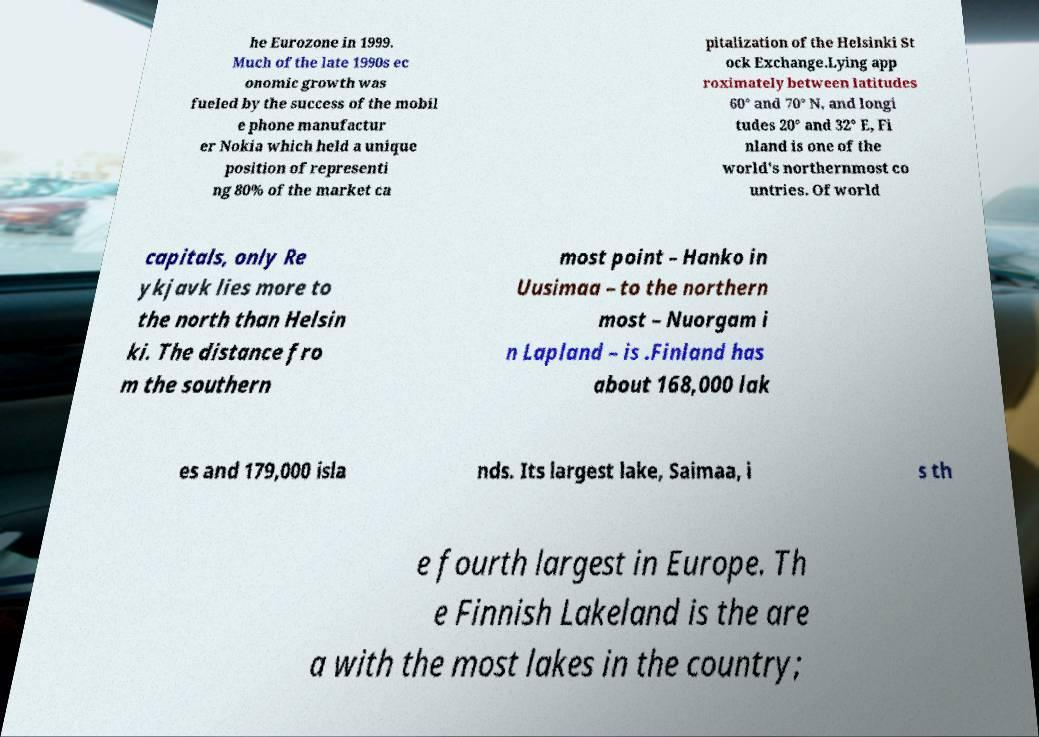Could you extract and type out the text from this image? he Eurozone in 1999. Much of the late 1990s ec onomic growth was fueled by the success of the mobil e phone manufactur er Nokia which held a unique position of representi ng 80% of the market ca pitalization of the Helsinki St ock Exchange.Lying app roximately between latitudes 60° and 70° N, and longi tudes 20° and 32° E, Fi nland is one of the world's northernmost co untries. Of world capitals, only Re ykjavk lies more to the north than Helsin ki. The distance fro m the southern most point – Hanko in Uusimaa – to the northern most – Nuorgam i n Lapland – is .Finland has about 168,000 lak es and 179,000 isla nds. Its largest lake, Saimaa, i s th e fourth largest in Europe. Th e Finnish Lakeland is the are a with the most lakes in the country; 